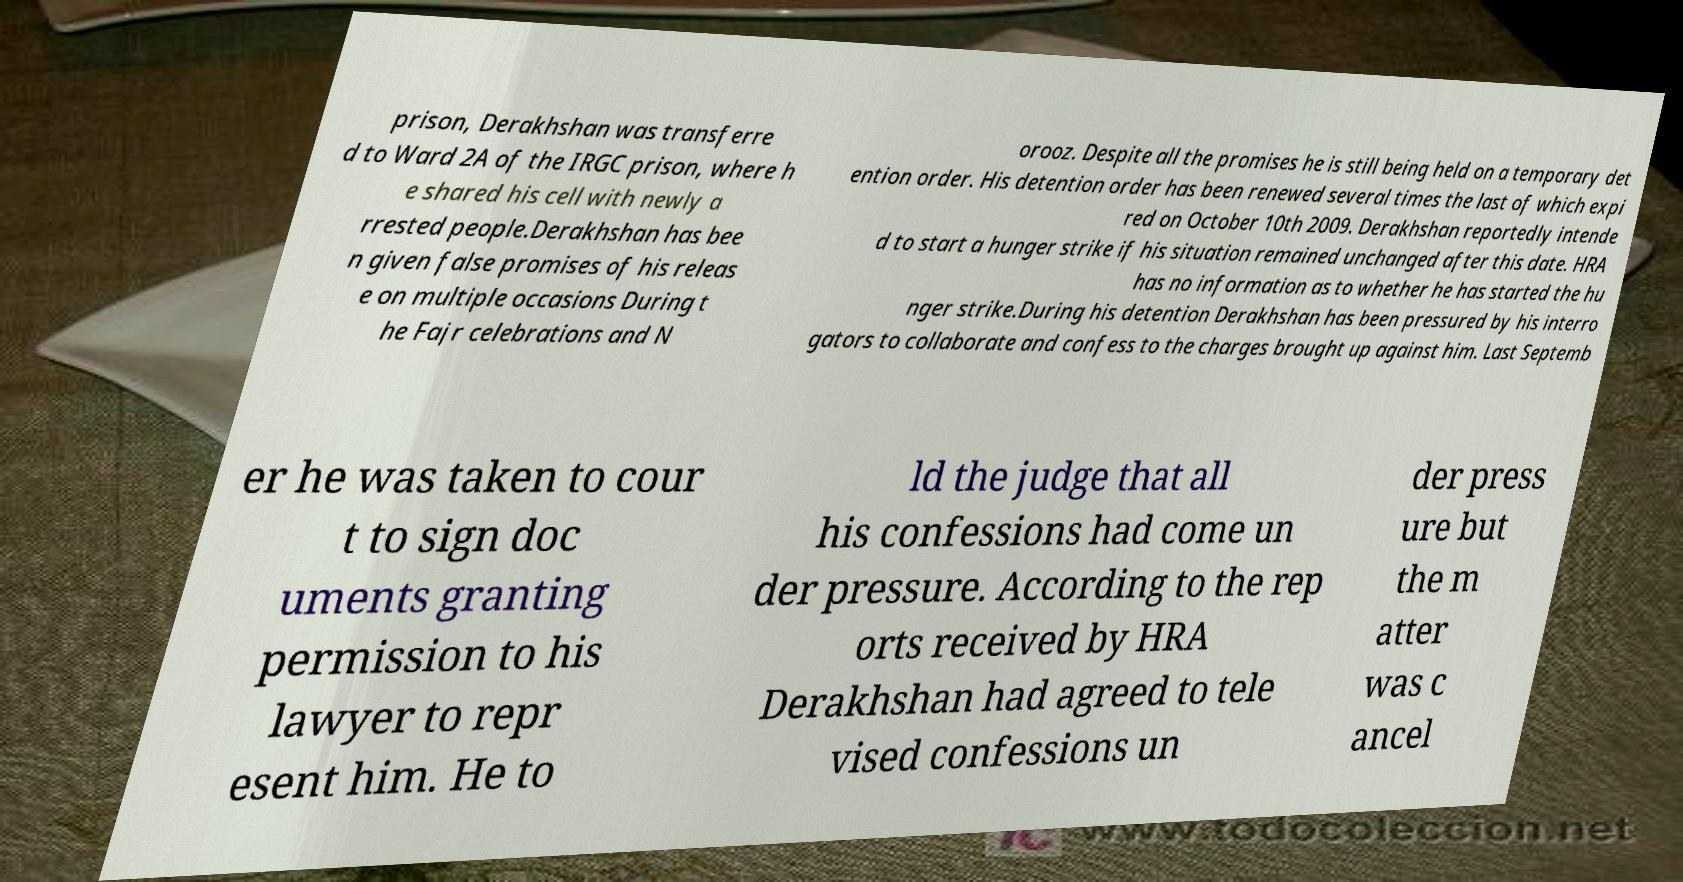Please identify and transcribe the text found in this image. prison, Derakhshan was transferre d to Ward 2A of the IRGC prison, where h e shared his cell with newly a rrested people.Derakhshan has bee n given false promises of his releas e on multiple occasions During t he Fajr celebrations and N orooz. Despite all the promises he is still being held on a temporary det ention order. His detention order has been renewed several times the last of which expi red on October 10th 2009. Derakhshan reportedly intende d to start a hunger strike if his situation remained unchanged after this date. HRA has no information as to whether he has started the hu nger strike.During his detention Derakhshan has been pressured by his interro gators to collaborate and confess to the charges brought up against him. Last Septemb er he was taken to cour t to sign doc uments granting permission to his lawyer to repr esent him. He to ld the judge that all his confessions had come un der pressure. According to the rep orts received by HRA Derakhshan had agreed to tele vised confessions un der press ure but the m atter was c ancel 